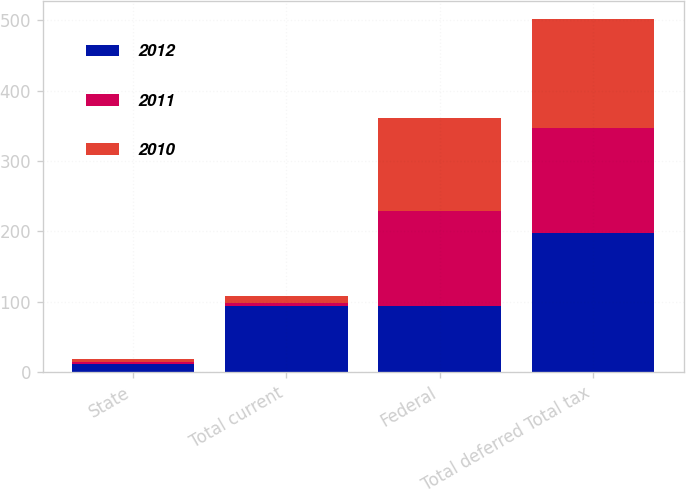<chart> <loc_0><loc_0><loc_500><loc_500><stacked_bar_chart><ecel><fcel>State<fcel>Total current<fcel>Federal<fcel>Total deferred Total tax<nl><fcel>2012<fcel>11<fcel>94<fcel>94<fcel>198<nl><fcel>2011<fcel>4<fcel>4<fcel>135<fcel>149<nl><fcel>2010<fcel>3<fcel>10<fcel>132<fcel>155<nl></chart> 